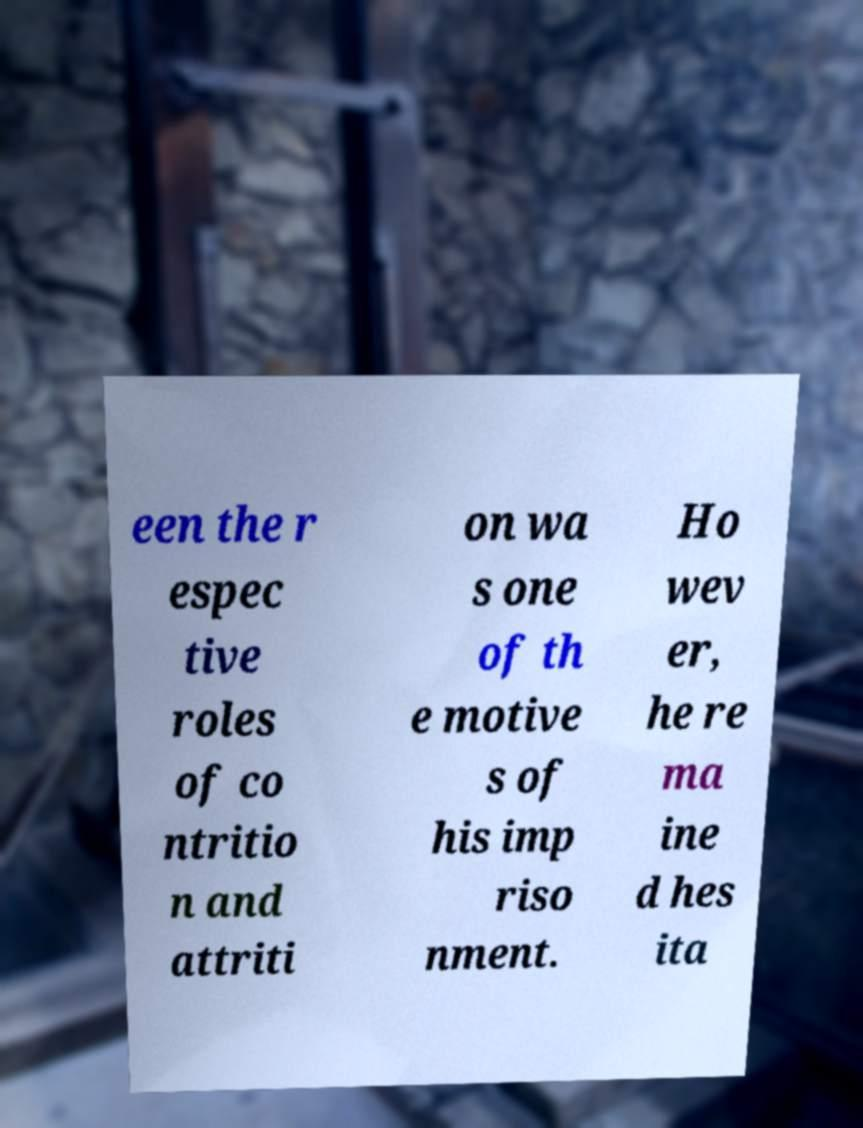I need the written content from this picture converted into text. Can you do that? een the r espec tive roles of co ntritio n and attriti on wa s one of th e motive s of his imp riso nment. Ho wev er, he re ma ine d hes ita 